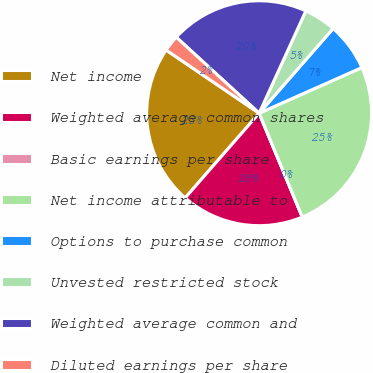<chart> <loc_0><loc_0><loc_500><loc_500><pie_chart><fcel>Net income<fcel>Weighted average common shares<fcel>Basic earnings per share<fcel>Net income attributable to<fcel>Options to purchase common<fcel>Unvested restricted stock<fcel>Weighted average common and<fcel>Diluted earnings per share<nl><fcel>23.07%<fcel>17.7%<fcel>0.0%<fcel>25.38%<fcel>6.92%<fcel>4.61%<fcel>20.01%<fcel>2.31%<nl></chart> 